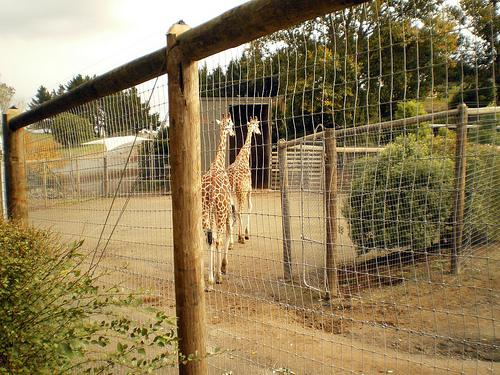Question: what type of fence is used?
Choices:
A. Wire.
B. Wooden.
C. Chain Link.
D. Metal.
Answer with the letter. Answer: A Question: who is in the scene?
Choices:
A. No one.
B. First responder.
C. Fireman.
D. Witnesses.
Answer with the letter. Answer: A Question: what type of animal is in the scene?
Choices:
A. Giraffe.
B. Bear and her cubs.
C. Kittens.
D. A horse.
Answer with the letter. Answer: A Question: how many giraffes are in the scene?
Choices:
A. Three.
B. Four.
C. Two.
D. Five.
Answer with the letter. Answer: C Question: where are the giraffes?
Choices:
A. In an enclosure.
B. In the field.
C. By the tree grazing.
D. Laying down.
Answer with the letter. Answer: A 